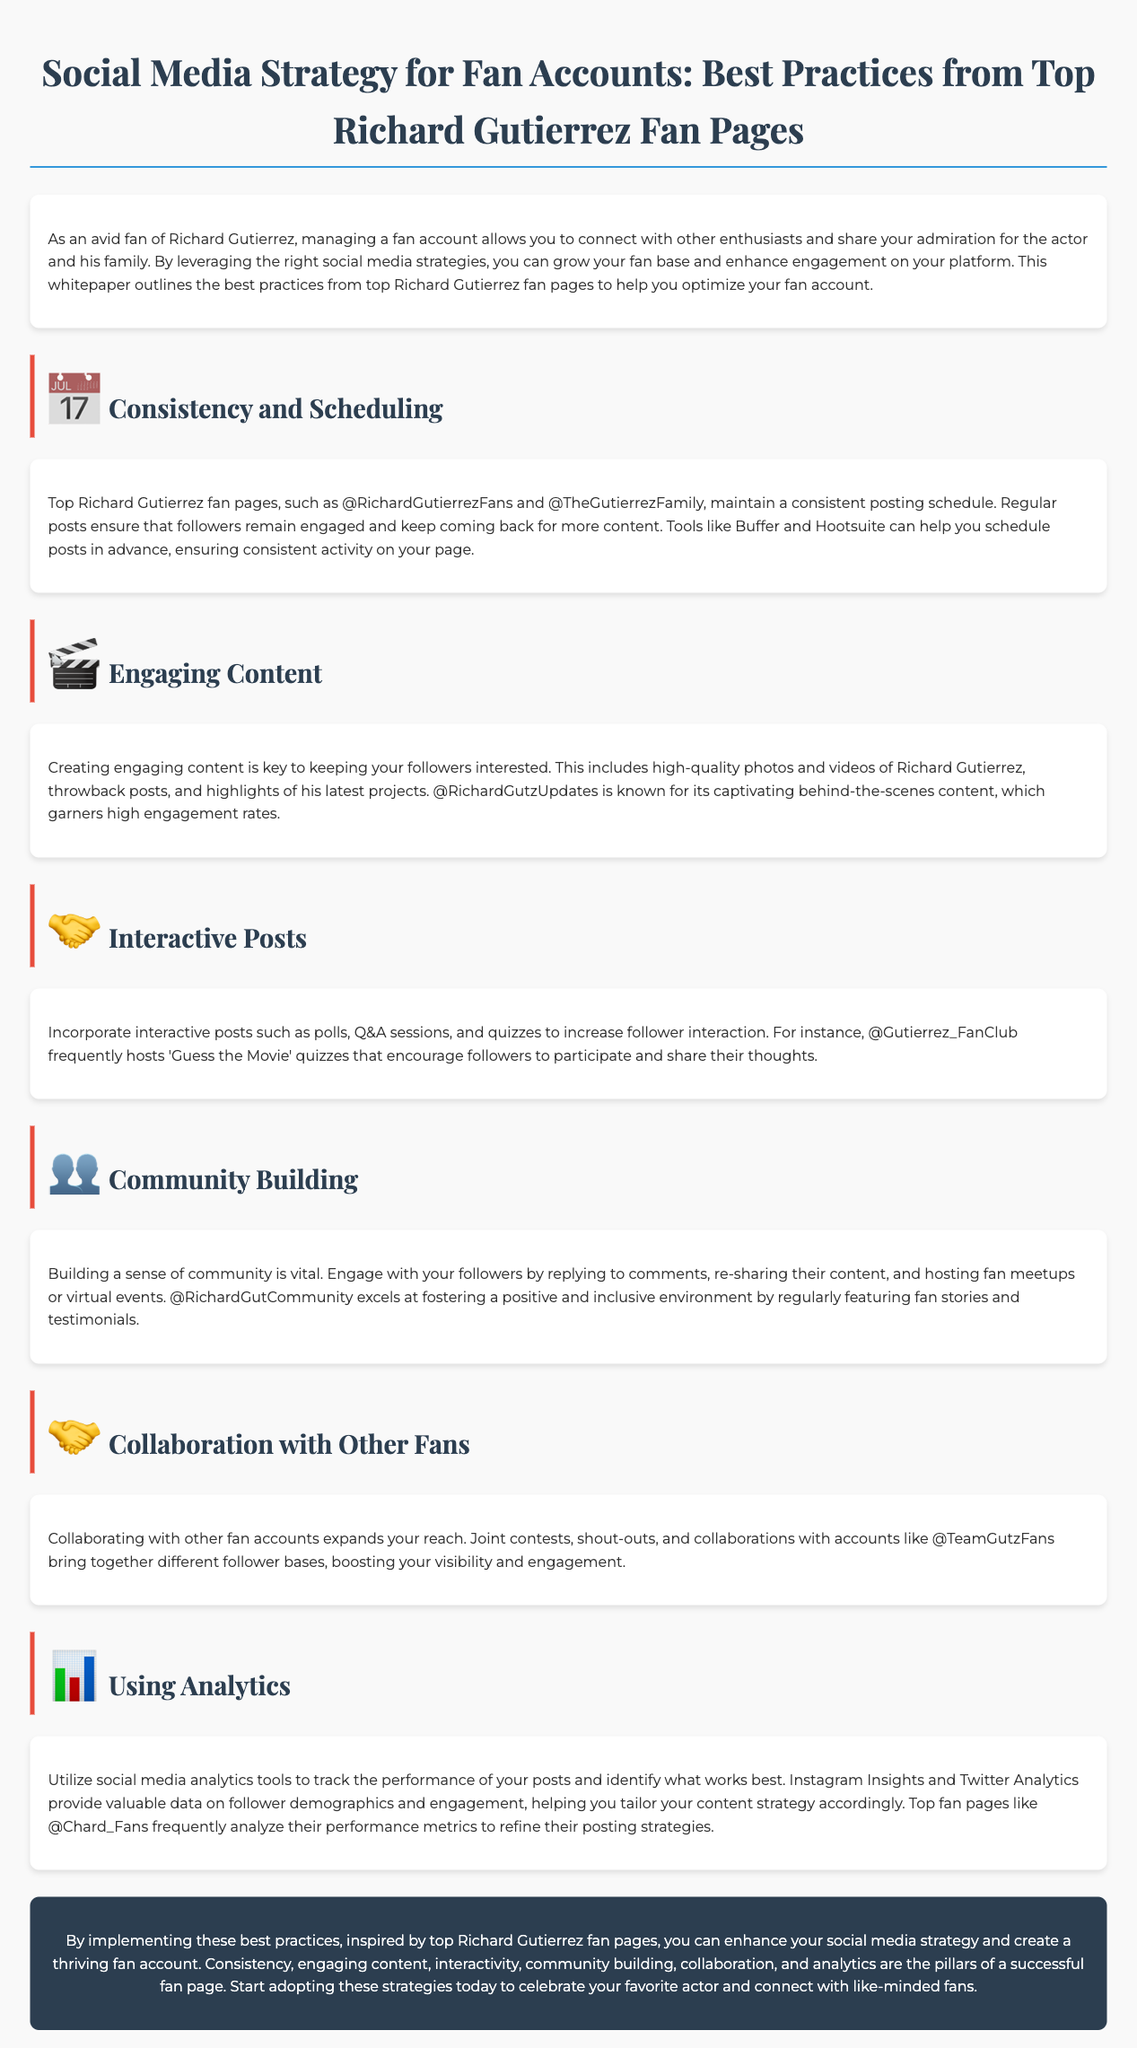what is the title of the whitepaper? The title outlines the focus of the document, which is "Social Media Strategy for Richard Gutierrez Fan Accounts: Best Practices from Top Richard Gutierrez Fan Pages."
Answer: Social Media Strategy for Richard Gutierrez Fan Accounts: Best Practices from Top Richard Gutierrez Fan Pages who is the subject of the fan accounts discussed? The document focuses on fan accounts dedicated to a specific actor, which is Richard Gutierrez.
Answer: Richard Gutierrez what is a tool suggested for scheduling posts? The document recommends using tools for maintaining a consistent posting schedule, specifically mentioning Buffer and Hootsuite.
Answer: Buffer and Hootsuite which fan page is known for engaging behind-the-scenes content? The document highlights a fan page recognized for its captivating behind-the-scenes content, specifically naming @RichardGutzUpdates.
Answer: @RichardGutzUpdates how frequently does @Gutierrez_FanClub host quizzes? The document specifies the nature of interactive posts by mentioning that @Gutierrez_FanClub frequently hosts quizzes, though it does not give a specific frequency.
Answer: Frequently what are two pillars of a successful fan page according to the document? The whitepaper outlines multiple strategies and mentions two pillars that are vital for success: consistency and engaging content.
Answer: Consistency and engaging content what types of interactive posts are recommended in the document? The document suggests various interactive post types, specifically mentioning polls, Q&A sessions, and quizzes.
Answer: Polls, Q&A sessions, and quizzes how does @RichardGutCommunity foster a positive environment? The document notes that @RichardGutCommunity fosters positivity by featuring fan stories and testimonials.
Answer: Featuring fan stories and testimonials which analytics tools are mentioned for tracking performance? The document lists specific tools for monitoring social media performance, including Instagram Insights and Twitter Analytics.
Answer: Instagram Insights and Twitter Analytics 